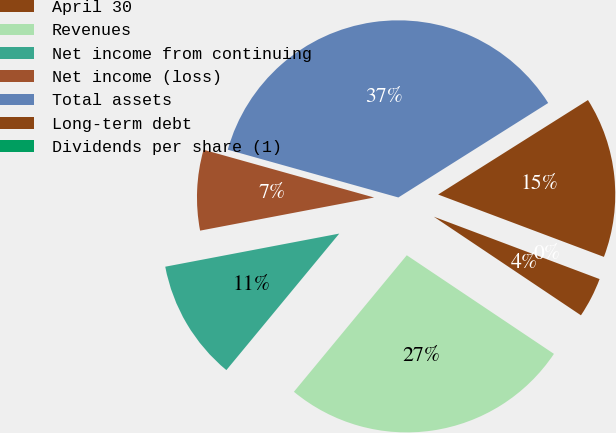Convert chart to OTSL. <chart><loc_0><loc_0><loc_500><loc_500><pie_chart><fcel>April 30<fcel>Revenues<fcel>Net income from continuing<fcel>Net income (loss)<fcel>Total assets<fcel>Long-term debt<fcel>Dividends per share (1)<nl><fcel>3.67%<fcel>26.6%<fcel>11.01%<fcel>7.34%<fcel>36.7%<fcel>14.68%<fcel>0.0%<nl></chart> 